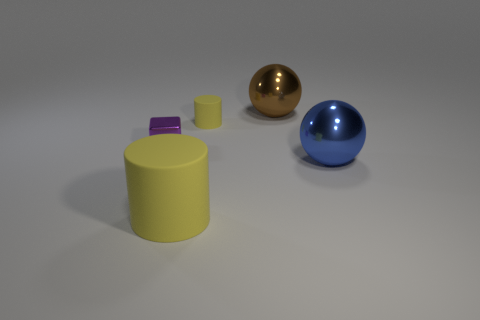Add 5 big brown things. How many objects exist? 10 Subtract all cubes. How many objects are left? 4 Subtract 1 blue balls. How many objects are left? 4 Subtract all tiny brown things. Subtract all tiny yellow matte cylinders. How many objects are left? 4 Add 1 brown things. How many brown things are left? 2 Add 4 large yellow things. How many large yellow things exist? 5 